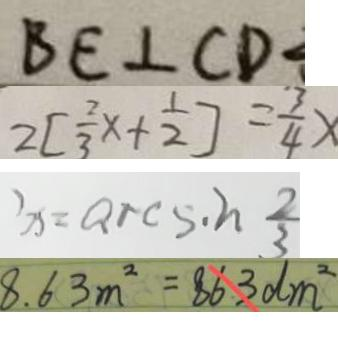Convert formula to latex. <formula><loc_0><loc_0><loc_500><loc_500>B E \bot C D 
 2 [ \frac { 2 } { 3 } x + \frac { 1 } { 2 } ] = \frac { 3 } { 4 } x 
 x = \arcsin \frac { 2 } { 3 } 
 8 . 6 3 m ^ { 2 } = 8 6 3 d m ^ { 2 }</formula> 